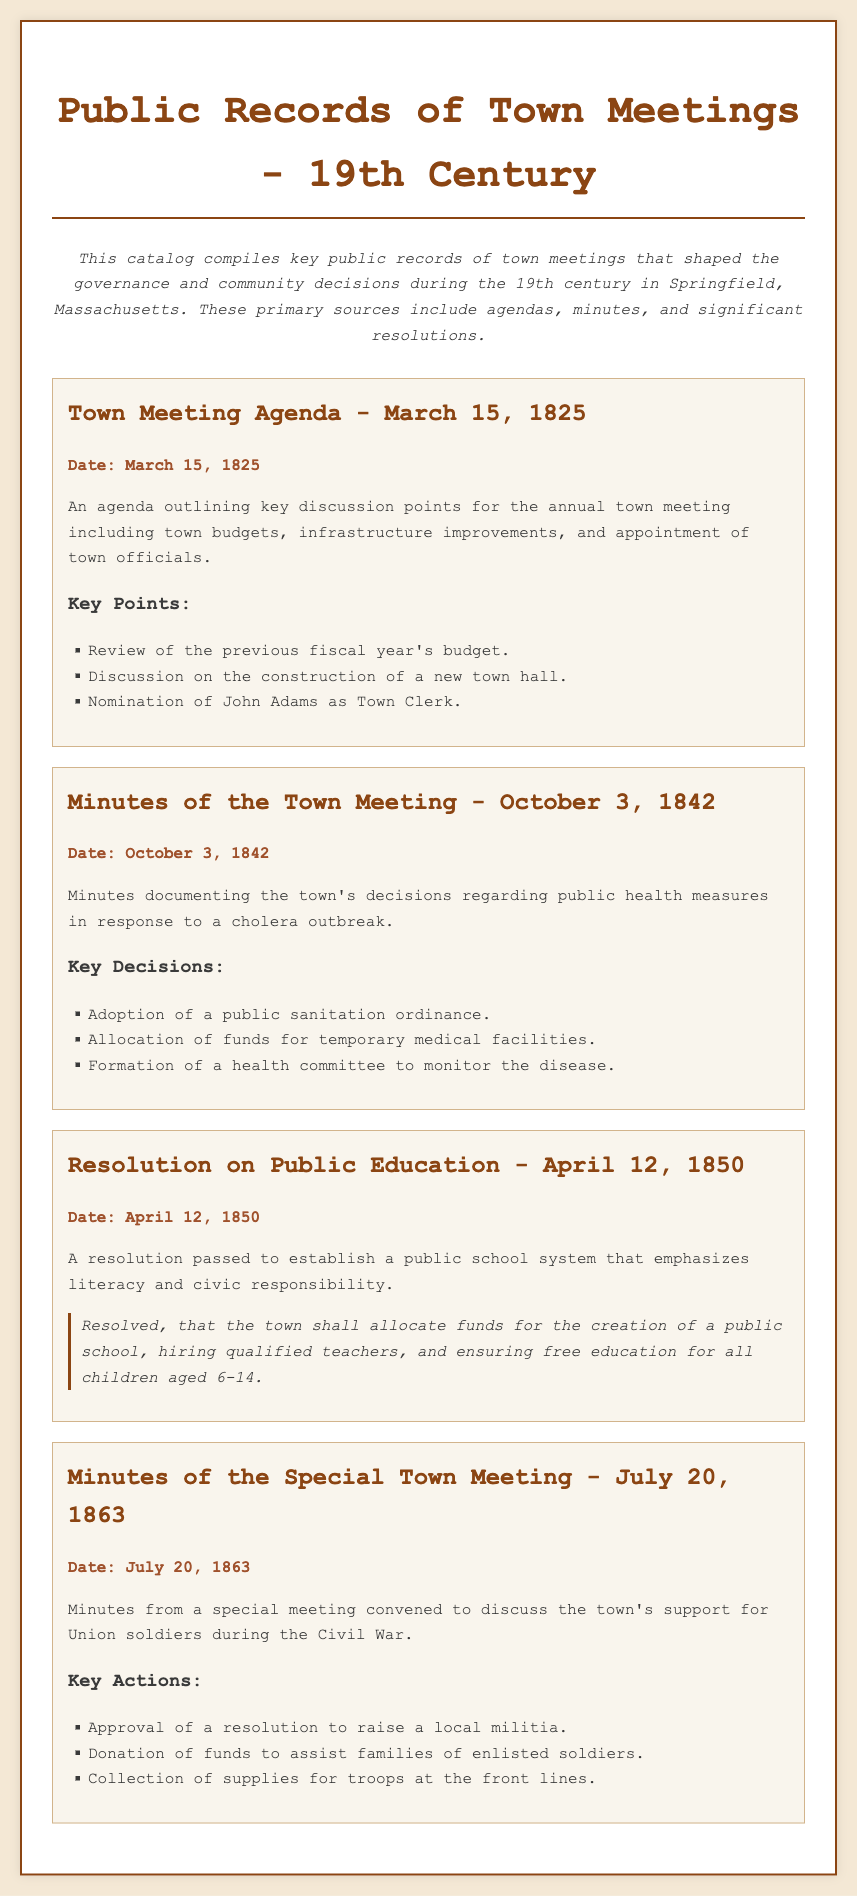What date was the Town Meeting Agenda? The document states the date of the agenda for the town meeting, which is clearly listed.
Answer: March 15, 1825 What was nominated at the March 15, 1825 meeting? The document includes a key point about a nomination from that meeting, indicating who was nominated for a position.
Answer: John Adams What type of ordinance was adopted on October 3, 1842? The minutes detail a specific type of ordinance that was adopted in response to public health concerns.
Answer: Public sanitation ordinance What significant resolution was passed on April 12, 1850? The resolution mentioned in the document is focused on public education, specifying what was decided.
Answer: Establish a public school system How many actions were discussed in the July 20, 1863 meeting? The document lists actions taken during that meeting, and the question seeks to determine the count of those actions.
Answer: Three What did the town allocate funds for in the education resolution? The document highlights what the funds were designated for in the resolution regarding education, emphasizing the main purpose.
Answer: Creation of a public school What was a key topic addressed on October 3, 1842? The minutes indicate a significant issue that was addressed during that town meeting, related to public health and safety.
Answer: Cholera outbreak What was collected for the troops during the Civil War as discussed in the meeting? The document lists one of the actions taken during the special town meeting, revealing what was gathered for army support.
Answer: Supplies 